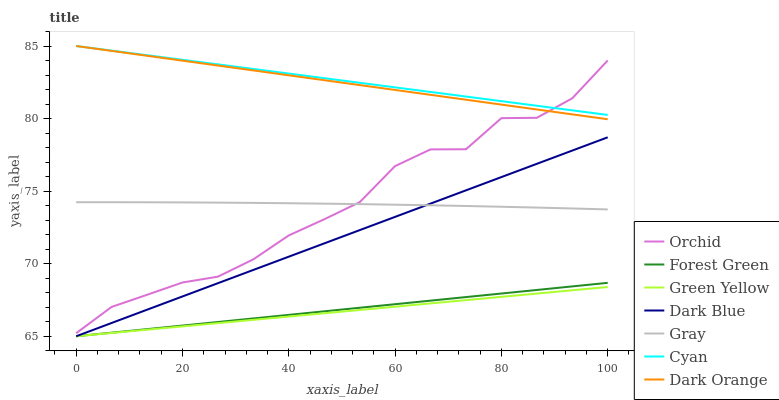Does Dark Orange have the minimum area under the curve?
Answer yes or no. No. Does Dark Orange have the maximum area under the curve?
Answer yes or no. No. Is Dark Orange the smoothest?
Answer yes or no. No. Is Dark Orange the roughest?
Answer yes or no. No. Does Dark Orange have the lowest value?
Answer yes or no. No. Does Dark Blue have the highest value?
Answer yes or no. No. Is Forest Green less than Gray?
Answer yes or no. Yes. Is Cyan greater than Green Yellow?
Answer yes or no. Yes. Does Forest Green intersect Gray?
Answer yes or no. No. 